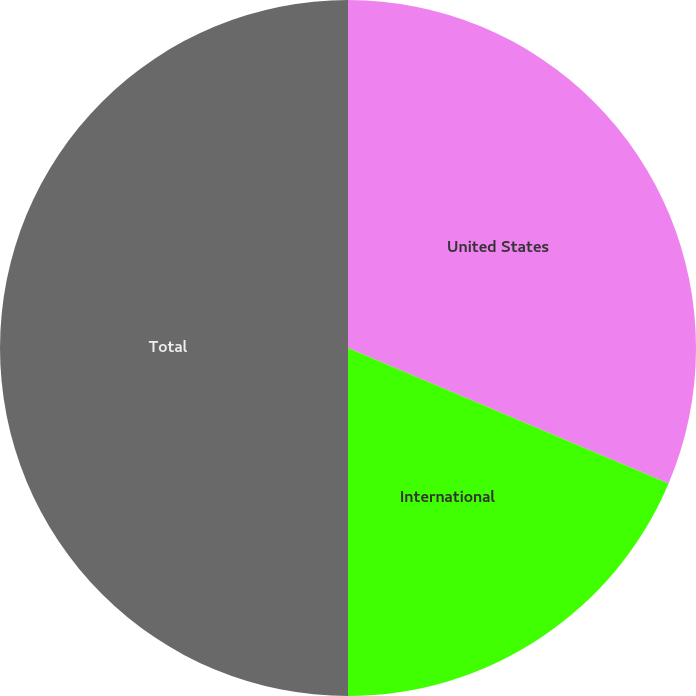Convert chart to OTSL. <chart><loc_0><loc_0><loc_500><loc_500><pie_chart><fcel>United States<fcel>International<fcel>Total<nl><fcel>31.36%<fcel>18.64%<fcel>50.0%<nl></chart> 